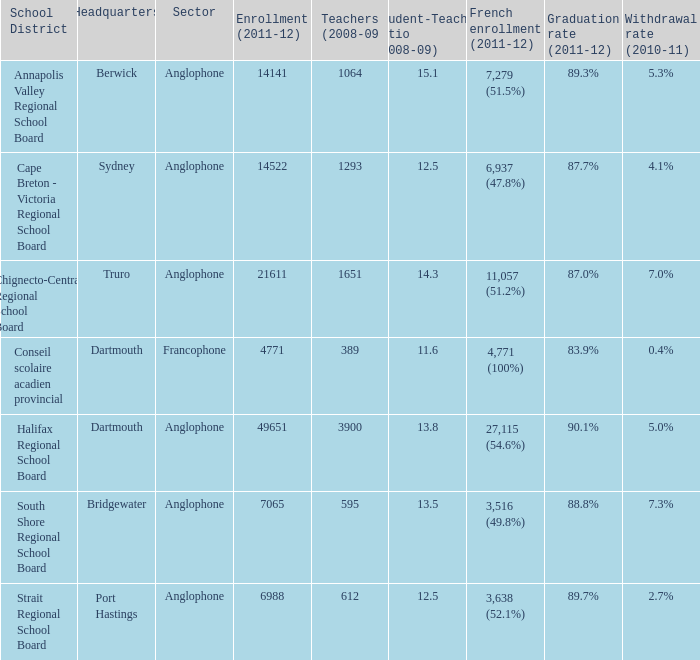Where is the headquarter located for the Annapolis Valley Regional School Board? Berwick. 